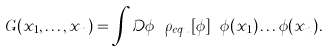<formula> <loc_0><loc_0><loc_500><loc_500>G ( x _ { 1 } , \dots , x _ { n } ) = \int \mathcal { D } \phi \ \rho _ { e q u } [ \phi ] \ \phi ( x _ { 1 } ) \dots \phi ( x _ { n } ) .</formula> 